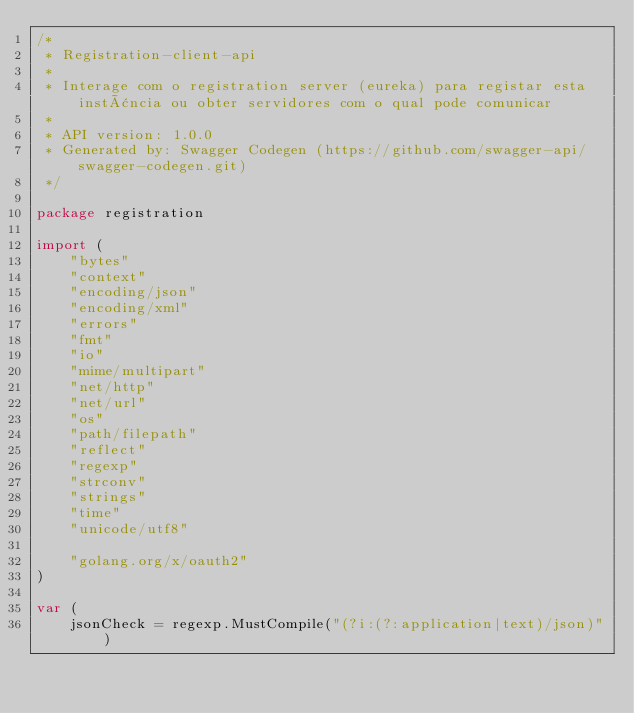Convert code to text. <code><loc_0><loc_0><loc_500><loc_500><_Go_>/*
 * Registration-client-api
 *
 * Interage com o registration server (eureka) para registar esta instância ou obter servidores com o qual pode comunicar
 *
 * API version: 1.0.0
 * Generated by: Swagger Codegen (https://github.com/swagger-api/swagger-codegen.git)
 */

package registration

import (
	"bytes"
	"context"
	"encoding/json"
	"encoding/xml"
	"errors"
	"fmt"
	"io"
	"mime/multipart"
	"net/http"
	"net/url"
	"os"
	"path/filepath"
	"reflect"
	"regexp"
	"strconv"
	"strings"
	"time"
	"unicode/utf8"

	"golang.org/x/oauth2"
)

var (
	jsonCheck = regexp.MustCompile("(?i:(?:application|text)/json)")</code> 